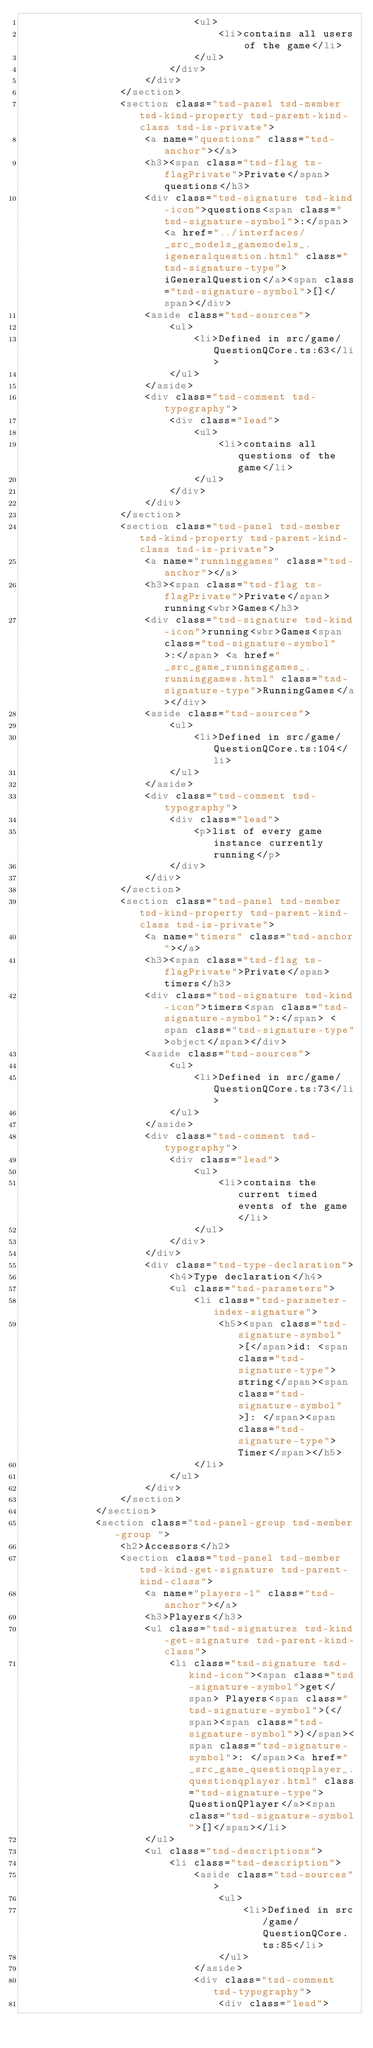Convert code to text. <code><loc_0><loc_0><loc_500><loc_500><_HTML_>							<ul>
								<li>contains all users of the game</li>
							</ul>
						</div>
					</div>
				</section>
				<section class="tsd-panel tsd-member tsd-kind-property tsd-parent-kind-class tsd-is-private">
					<a name="questions" class="tsd-anchor"></a>
					<h3><span class="tsd-flag ts-flagPrivate">Private</span> questions</h3>
					<div class="tsd-signature tsd-kind-icon">questions<span class="tsd-signature-symbol">:</span> <a href="../interfaces/_src_models_gamemodels_.igeneralquestion.html" class="tsd-signature-type">iGeneralQuestion</a><span class="tsd-signature-symbol">[]</span></div>
					<aside class="tsd-sources">
						<ul>
							<li>Defined in src/game/QuestionQCore.ts:63</li>
						</ul>
					</aside>
					<div class="tsd-comment tsd-typography">
						<div class="lead">
							<ul>
								<li>contains all questions of the game</li>
							</ul>
						</div>
					</div>
				</section>
				<section class="tsd-panel tsd-member tsd-kind-property tsd-parent-kind-class tsd-is-private">
					<a name="runninggames" class="tsd-anchor"></a>
					<h3><span class="tsd-flag ts-flagPrivate">Private</span> running<wbr>Games</h3>
					<div class="tsd-signature tsd-kind-icon">running<wbr>Games<span class="tsd-signature-symbol">:</span> <a href="_src_game_runninggames_.runninggames.html" class="tsd-signature-type">RunningGames</a></div>
					<aside class="tsd-sources">
						<ul>
							<li>Defined in src/game/QuestionQCore.ts:104</li>
						</ul>
					</aside>
					<div class="tsd-comment tsd-typography">
						<div class="lead">
							<p>list of every game instance currently running</p>
						</div>
					</div>
				</section>
				<section class="tsd-panel tsd-member tsd-kind-property tsd-parent-kind-class tsd-is-private">
					<a name="timers" class="tsd-anchor"></a>
					<h3><span class="tsd-flag ts-flagPrivate">Private</span> timers</h3>
					<div class="tsd-signature tsd-kind-icon">timers<span class="tsd-signature-symbol">:</span> <span class="tsd-signature-type">object</span></div>
					<aside class="tsd-sources">
						<ul>
							<li>Defined in src/game/QuestionQCore.ts:73</li>
						</ul>
					</aside>
					<div class="tsd-comment tsd-typography">
						<div class="lead">
							<ul>
								<li>contains the current timed events of the game</li>
							</ul>
						</div>
					</div>
					<div class="tsd-type-declaration">
						<h4>Type declaration</h4>
						<ul class="tsd-parameters">
							<li class="tsd-parameter-index-signature">
								<h5><span class="tsd-signature-symbol">[</span>id: <span class="tsd-signature-type">string</span><span class="tsd-signature-symbol">]: </span><span class="tsd-signature-type">Timer</span></h5>
							</li>
						</ul>
					</div>
				</section>
			</section>
			<section class="tsd-panel-group tsd-member-group ">
				<h2>Accessors</h2>
				<section class="tsd-panel tsd-member tsd-kind-get-signature tsd-parent-kind-class">
					<a name="players-1" class="tsd-anchor"></a>
					<h3>Players</h3>
					<ul class="tsd-signatures tsd-kind-get-signature tsd-parent-kind-class">
						<li class="tsd-signature tsd-kind-icon"><span class="tsd-signature-symbol">get</span> Players<span class="tsd-signature-symbol">(</span><span class="tsd-signature-symbol">)</span><span class="tsd-signature-symbol">: </span><a href="_src_game_questionqplayer_.questionqplayer.html" class="tsd-signature-type">QuestionQPlayer</a><span class="tsd-signature-symbol">[]</span></li>
					</ul>
					<ul class="tsd-descriptions">
						<li class="tsd-description">
							<aside class="tsd-sources">
								<ul>
									<li>Defined in src/game/QuestionQCore.ts:85</li>
								</ul>
							</aside>
							<div class="tsd-comment tsd-typography">
								<div class="lead"></code> 